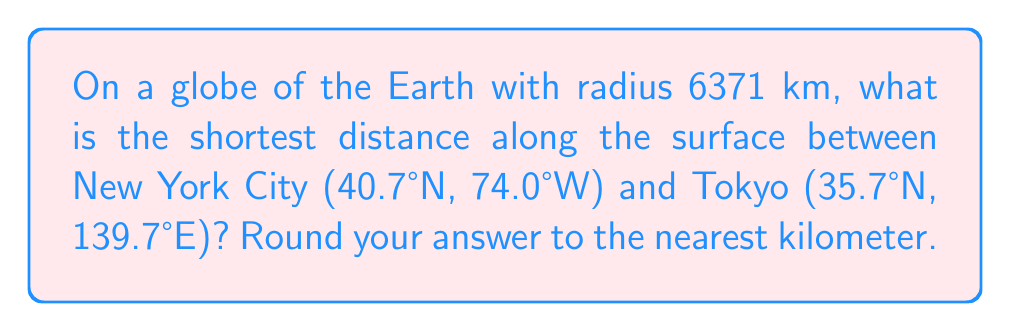Can you solve this math problem? Let's approach this step-by-step:

1) The shortest path between two points on a sphere is along a great circle, which is called a geodesic.

2) To find the distance, we need to use the spherical law of cosines:

   $$\cos(c) = \sin(a)\sin(b) + \cos(a)\cos(b)\cos(C)$$

   Where $c$ is the central angle, $a$ and $b$ are the latitudes, and $C$ is the difference in longitudes.

3) Convert the coordinates to radians:
   New York: $a = 40.7° \times \frac{\pi}{180} = 0.7101$ radians
   Tokyo: $b = 35.7° \times \frac{\pi}{180} = 0.6230$ radians

4) Calculate the difference in longitude:
   $C = |74.0°W - 139.7°E| = 213.7° \times \frac{\pi}{180} = 3.7293$ radians

5) Apply the formula:
   $$\cos(c) = \sin(0.7101)\sin(0.6230) + \cos(0.7101)\cos(0.6230)\cos(3.7293)$$

6) Solve for $c$:
   $$c = \arccos(\sin(0.7101)\sin(0.6230) + \cos(0.7101)\cos(0.6230)\cos(3.7293))$$
   $$c \approx 1.7496$$ radians

7) The distance $d$ along the surface is:
   $$d = R \times c$$
   Where $R$ is the radius of the Earth (6371 km).

8) Calculate the distance:
   $$d = 6371 \times 1.7496 \approx 11146.7$$ km

9) Rounding to the nearest kilometer:
   $$d \approx 11147$$ km
Answer: 11147 km 